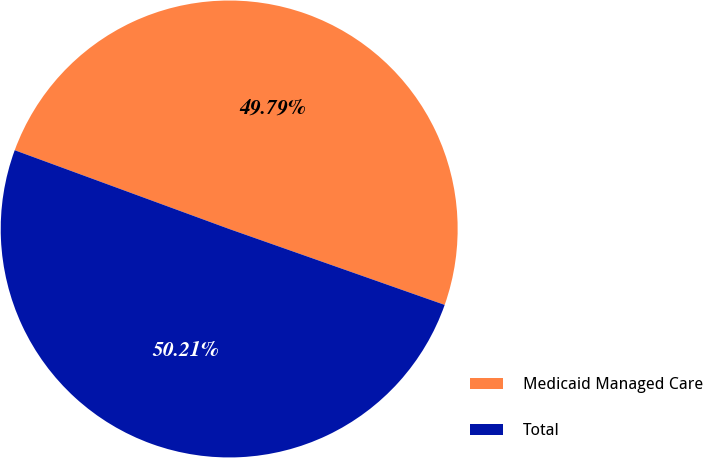<chart> <loc_0><loc_0><loc_500><loc_500><pie_chart><fcel>Medicaid Managed Care<fcel>Total<nl><fcel>49.79%<fcel>50.21%<nl></chart> 